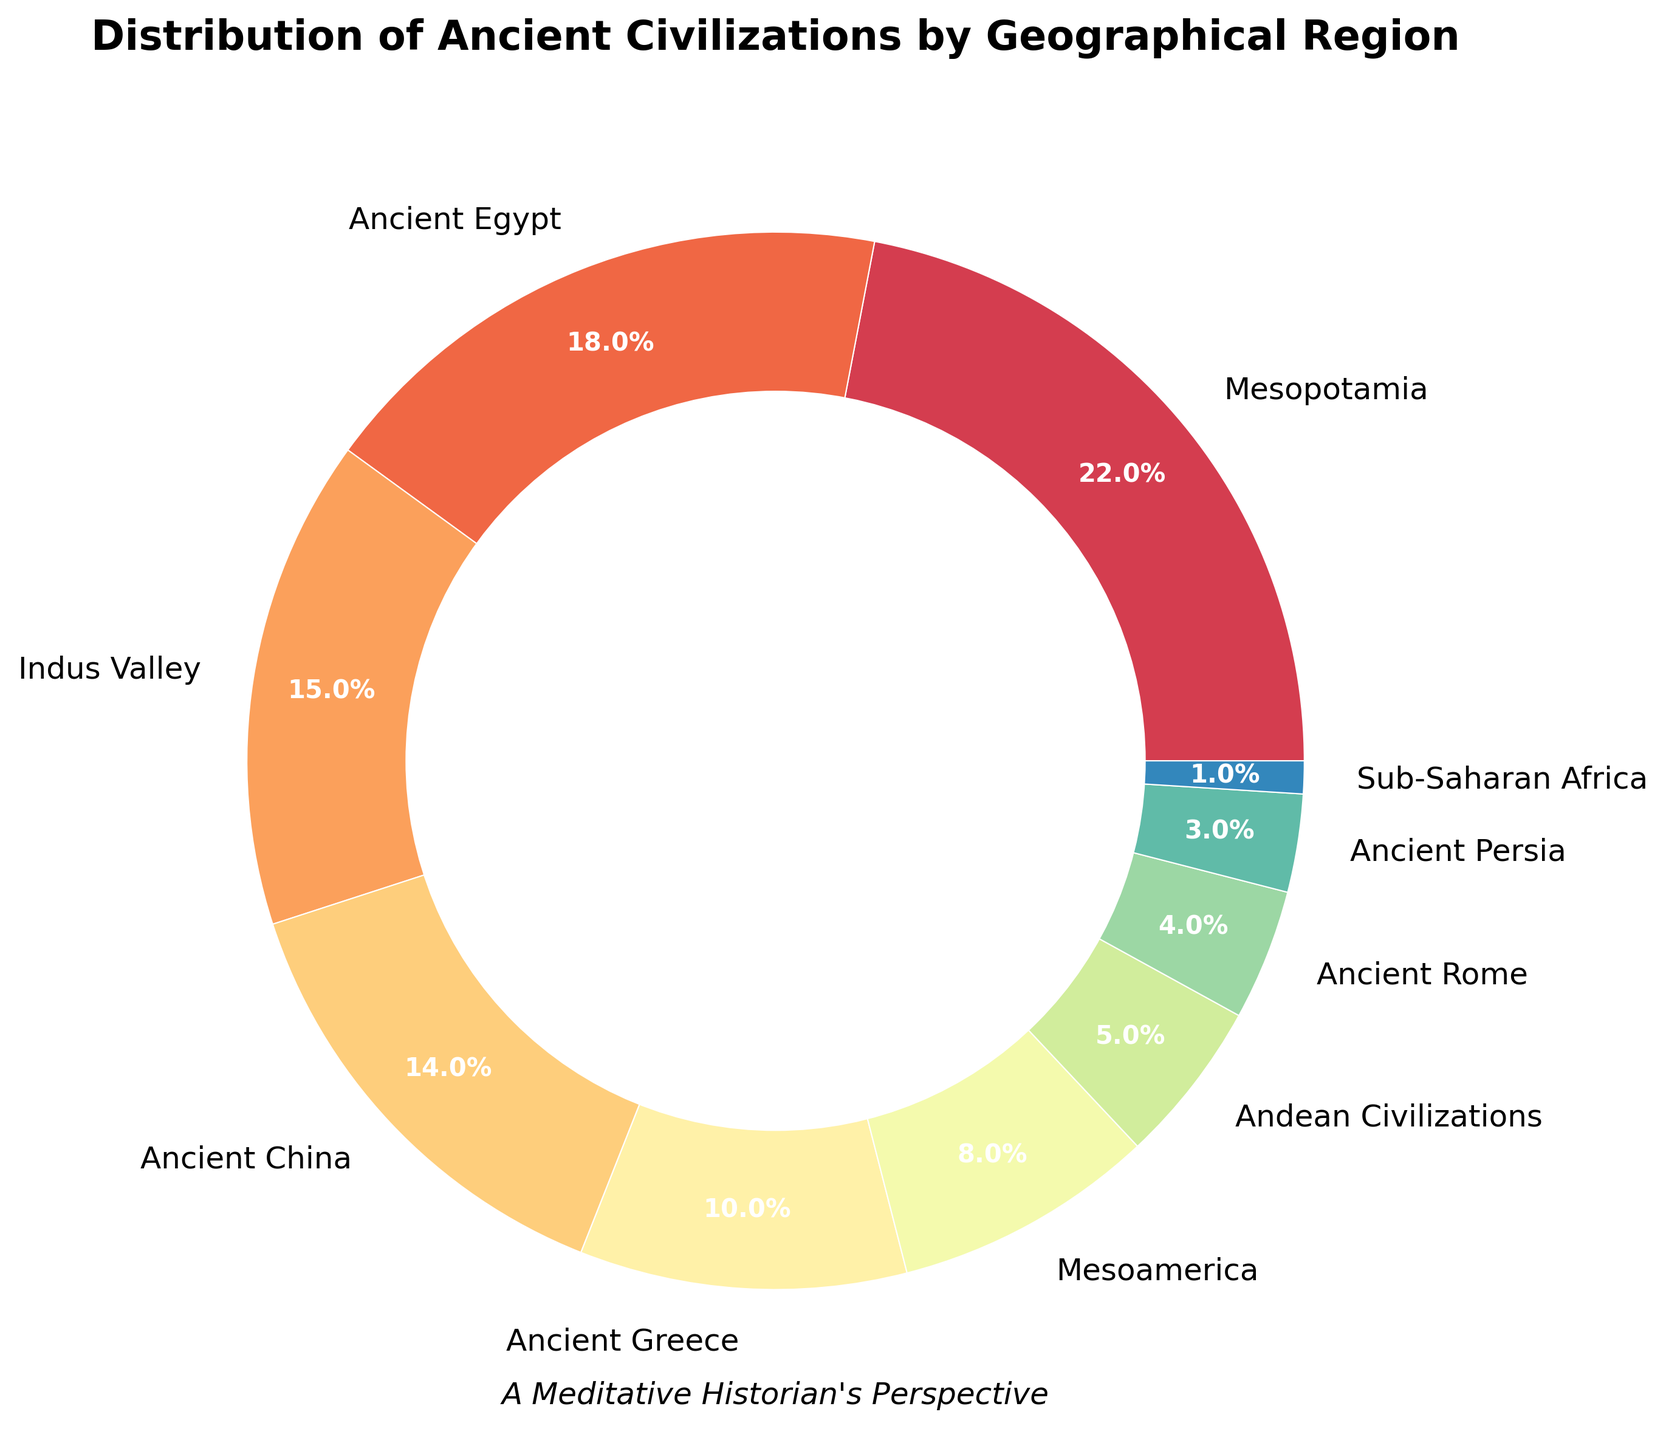Which region accounts for the largest percentage of ancient civilizations? The figure shows that Mesopotamia has the highest percentage among all the listed regions.
Answer: Mesopotamia Which two regions together account for more than one-third of the total distribution? Adding the percentages of Mesopotamia (22%) and Ancient Egypt (18%) yields 40%, which is more than one-third (33.3%).
Answer: Mesopotamia and Ancient Egypt How much more percentage does Ancient Greece account for compared to Ancient Rome? Ancient Greece accounts for 10% while Ancient Rome accounts for 4%. The difference is 10% - 4% = 6%.
Answer: 6% Which region represents the smallest segment in the pie chart? The figure shows that Sub-Saharan Africa accounts for the smallest percentage of 1%.
Answer: Sub-Saharan Africa What is the combined percentage of Andean Civilizations and Ancient Persia? Adding the percentages of Andean Civilizations (5%) and Ancient Persia (3%) yields 5% + 3% = 8%.
Answer: 8% How does the percentage of Ancient China compare to that of the Indus Valley? Ancient China accounts for 14% while the Indus Valley accounts for 15%. Ancient China is 1% less than the Indus Valley.
Answer: 1% less What percentage do regions associated with Western civilizations (Ancient Greece and Ancient Rome) represent combined? Adding the percentages of Ancient Greece (10%) and Ancient Rome (4%) yields 10% + 4% = 14%.
Answer: 14% If Mesopotamia and Ancient Egypt combined form a single region, what fraction of the total distribution do they account for? Combining Mesopotamia (22%) and Ancient Egypt (18%) gives 40%. Converting 40% to a fraction results in 40/100 = 2/5.
Answer: 2/5 What is the percentage difference between the highest and lowest represented regions? The highest percentage is Mesopotamia with 22%, and the lowest is Sub-Saharan Africa with 1%. The difference is 22% - 1% = 21%.
Answer: 21% Which region's percentage is closest to the average of all the percentages? Calculating the average: (22 + 18 + 15 + 14 + 10 + 8 + 5 + 4 + 3 + 1) / 10 = 10%. The closest region to 10% is Ancient Greece at 10%.
Answer: Ancient Greece 